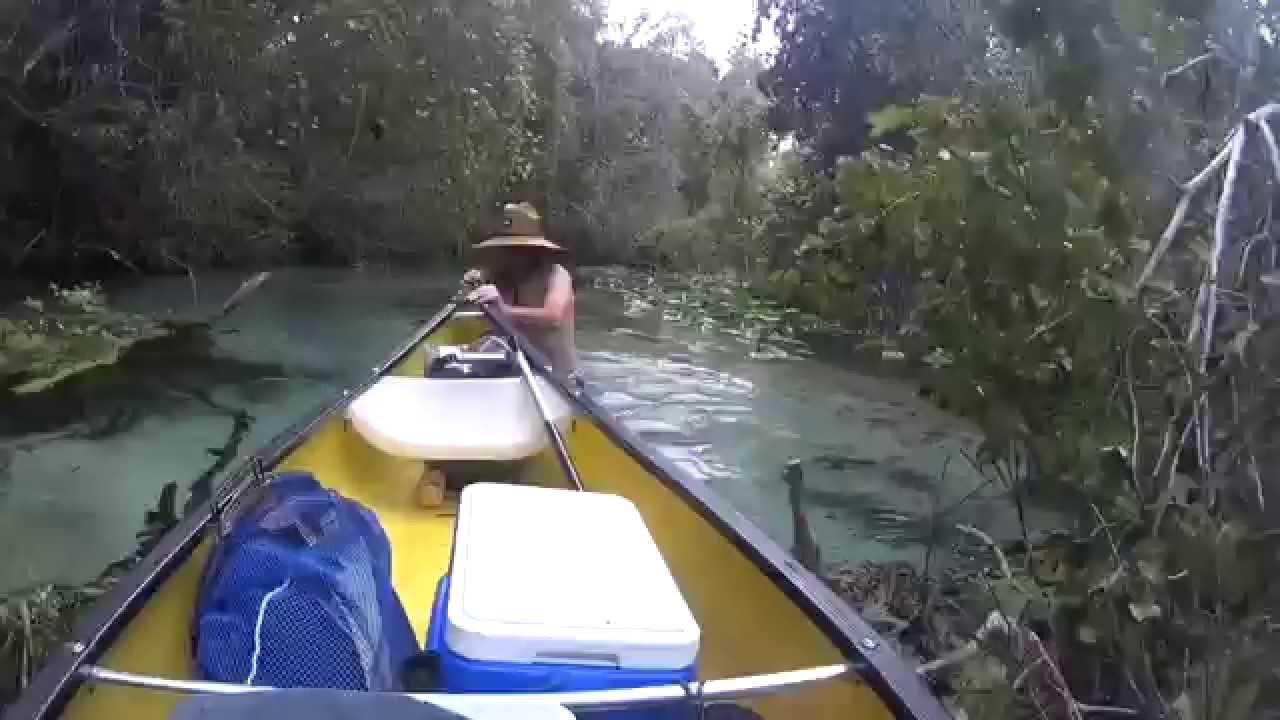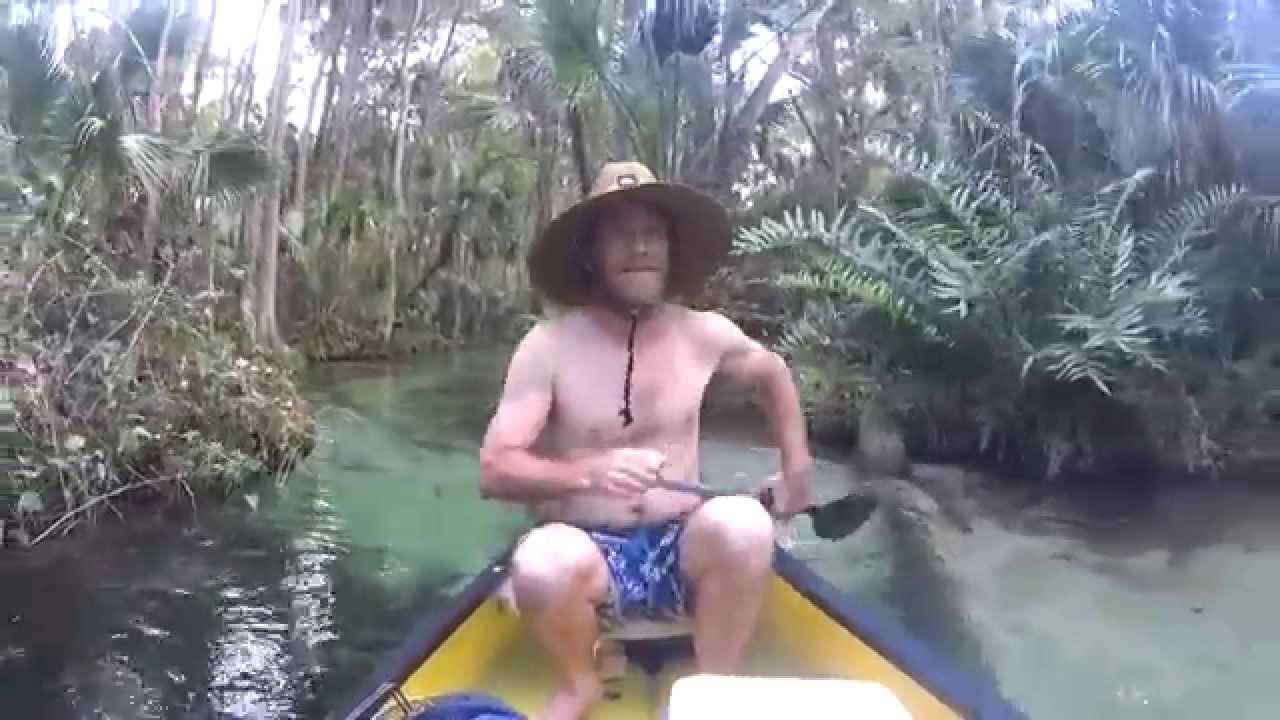The first image is the image on the left, the second image is the image on the right. Assess this claim about the two images: "woman in bikinis riding in canoes". Correct or not? Answer yes or no. No. The first image is the image on the left, the second image is the image on the right. Evaluate the accuracy of this statement regarding the images: "There is no more than one human in the right image wearing a hat.". Is it true? Answer yes or no. Yes. 